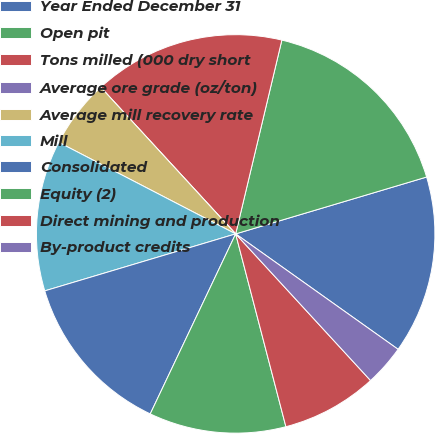Convert chart. <chart><loc_0><loc_0><loc_500><loc_500><pie_chart><fcel>Year Ended December 31<fcel>Open pit<fcel>Tons milled (000 dry short<fcel>Average ore grade (oz/ton)<fcel>Average mill recovery rate<fcel>Mill<fcel>Consolidated<fcel>Equity (2)<fcel>Direct mining and production<fcel>By-product credits<nl><fcel>14.44%<fcel>16.67%<fcel>15.56%<fcel>0.0%<fcel>5.56%<fcel>12.22%<fcel>13.33%<fcel>11.11%<fcel>7.78%<fcel>3.33%<nl></chart> 